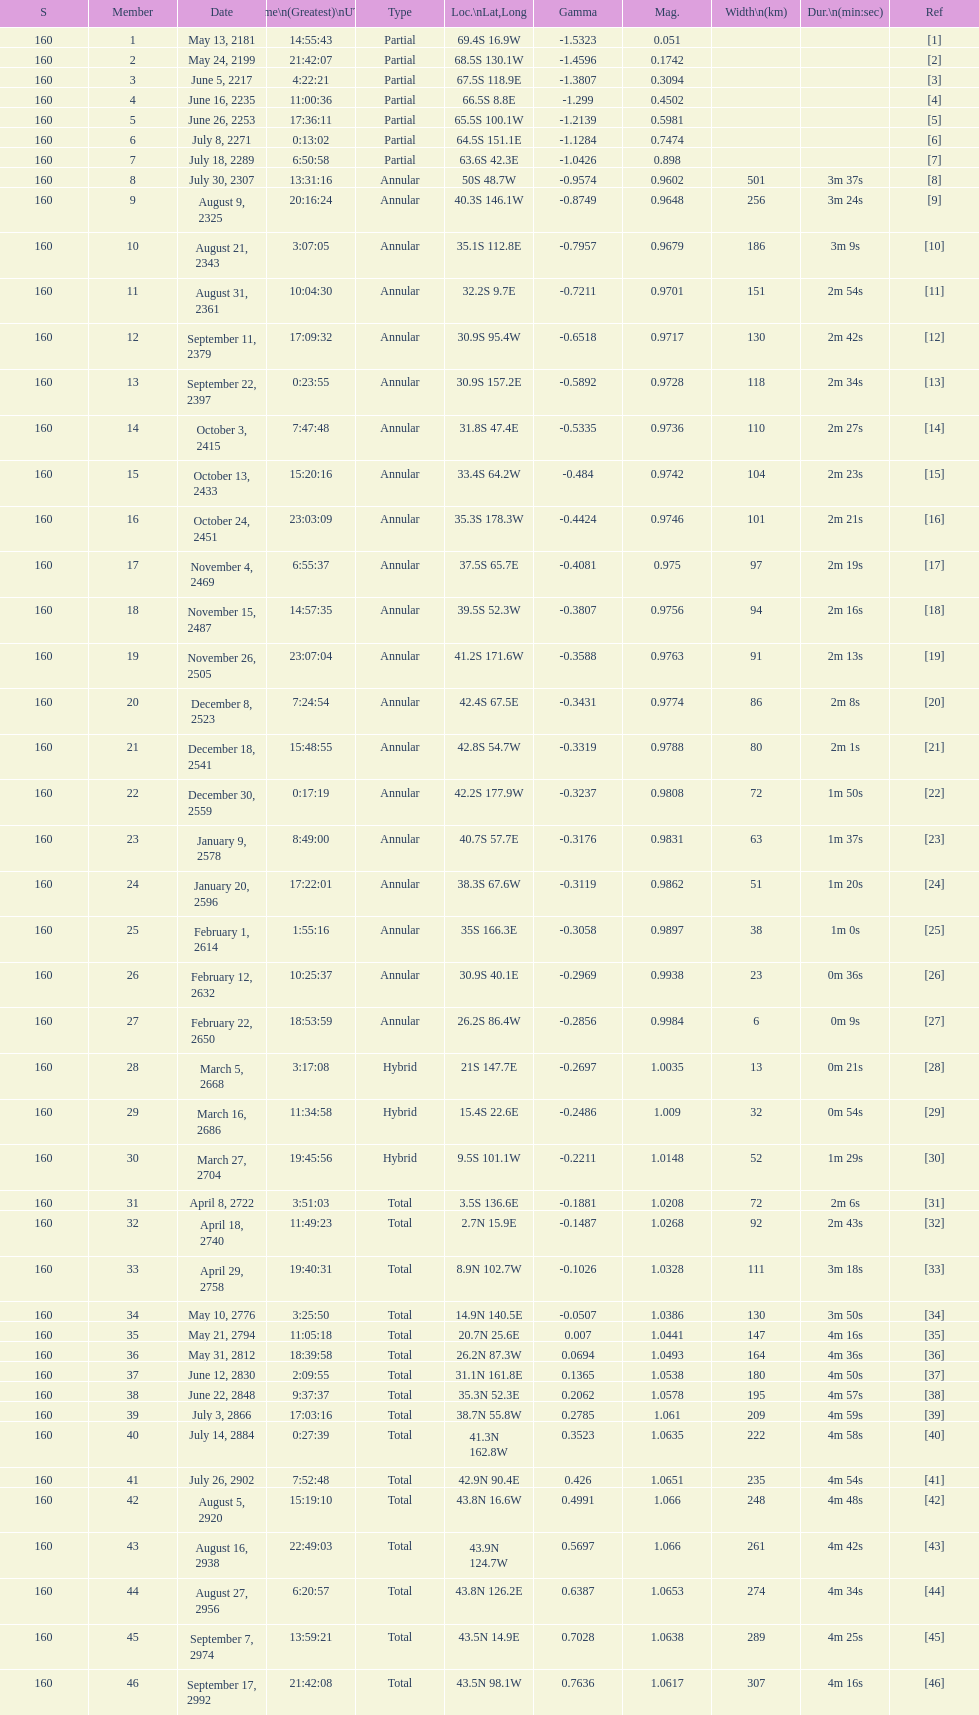How many solar saros events lasted longer than 4 minutes? 12. Can you give me this table as a dict? {'header': ['S', 'Member', 'Date', 'Time\\n(Greatest)\\nUTC', 'Type', 'Loc.\\nLat,Long', 'Gamma', 'Mag.', 'Width\\n(km)', 'Dur.\\n(min:sec)', 'Ref'], 'rows': [['160', '1', 'May 13, 2181', '14:55:43', 'Partial', '69.4S 16.9W', '-1.5323', '0.051', '', '', '[1]'], ['160', '2', 'May 24, 2199', '21:42:07', 'Partial', '68.5S 130.1W', '-1.4596', '0.1742', '', '', '[2]'], ['160', '3', 'June 5, 2217', '4:22:21', 'Partial', '67.5S 118.9E', '-1.3807', '0.3094', '', '', '[3]'], ['160', '4', 'June 16, 2235', '11:00:36', 'Partial', '66.5S 8.8E', '-1.299', '0.4502', '', '', '[4]'], ['160', '5', 'June 26, 2253', '17:36:11', 'Partial', '65.5S 100.1W', '-1.2139', '0.5981', '', '', '[5]'], ['160', '6', 'July 8, 2271', '0:13:02', 'Partial', '64.5S 151.1E', '-1.1284', '0.7474', '', '', '[6]'], ['160', '7', 'July 18, 2289', '6:50:58', 'Partial', '63.6S 42.3E', '-1.0426', '0.898', '', '', '[7]'], ['160', '8', 'July 30, 2307', '13:31:16', 'Annular', '50S 48.7W', '-0.9574', '0.9602', '501', '3m 37s', '[8]'], ['160', '9', 'August 9, 2325', '20:16:24', 'Annular', '40.3S 146.1W', '-0.8749', '0.9648', '256', '3m 24s', '[9]'], ['160', '10', 'August 21, 2343', '3:07:05', 'Annular', '35.1S 112.8E', '-0.7957', '0.9679', '186', '3m 9s', '[10]'], ['160', '11', 'August 31, 2361', '10:04:30', 'Annular', '32.2S 9.7E', '-0.7211', '0.9701', '151', '2m 54s', '[11]'], ['160', '12', 'September 11, 2379', '17:09:32', 'Annular', '30.9S 95.4W', '-0.6518', '0.9717', '130', '2m 42s', '[12]'], ['160', '13', 'September 22, 2397', '0:23:55', 'Annular', '30.9S 157.2E', '-0.5892', '0.9728', '118', '2m 34s', '[13]'], ['160', '14', 'October 3, 2415', '7:47:48', 'Annular', '31.8S 47.4E', '-0.5335', '0.9736', '110', '2m 27s', '[14]'], ['160', '15', 'October 13, 2433', '15:20:16', 'Annular', '33.4S 64.2W', '-0.484', '0.9742', '104', '2m 23s', '[15]'], ['160', '16', 'October 24, 2451', '23:03:09', 'Annular', '35.3S 178.3W', '-0.4424', '0.9746', '101', '2m 21s', '[16]'], ['160', '17', 'November 4, 2469', '6:55:37', 'Annular', '37.5S 65.7E', '-0.4081', '0.975', '97', '2m 19s', '[17]'], ['160', '18', 'November 15, 2487', '14:57:35', 'Annular', '39.5S 52.3W', '-0.3807', '0.9756', '94', '2m 16s', '[18]'], ['160', '19', 'November 26, 2505', '23:07:04', 'Annular', '41.2S 171.6W', '-0.3588', '0.9763', '91', '2m 13s', '[19]'], ['160', '20', 'December 8, 2523', '7:24:54', 'Annular', '42.4S 67.5E', '-0.3431', '0.9774', '86', '2m 8s', '[20]'], ['160', '21', 'December 18, 2541', '15:48:55', 'Annular', '42.8S 54.7W', '-0.3319', '0.9788', '80', '2m 1s', '[21]'], ['160', '22', 'December 30, 2559', '0:17:19', 'Annular', '42.2S 177.9W', '-0.3237', '0.9808', '72', '1m 50s', '[22]'], ['160', '23', 'January 9, 2578', '8:49:00', 'Annular', '40.7S 57.7E', '-0.3176', '0.9831', '63', '1m 37s', '[23]'], ['160', '24', 'January 20, 2596', '17:22:01', 'Annular', '38.3S 67.6W', '-0.3119', '0.9862', '51', '1m 20s', '[24]'], ['160', '25', 'February 1, 2614', '1:55:16', 'Annular', '35S 166.3E', '-0.3058', '0.9897', '38', '1m 0s', '[25]'], ['160', '26', 'February 12, 2632', '10:25:37', 'Annular', '30.9S 40.1E', '-0.2969', '0.9938', '23', '0m 36s', '[26]'], ['160', '27', 'February 22, 2650', '18:53:59', 'Annular', '26.2S 86.4W', '-0.2856', '0.9984', '6', '0m 9s', '[27]'], ['160', '28', 'March 5, 2668', '3:17:08', 'Hybrid', '21S 147.7E', '-0.2697', '1.0035', '13', '0m 21s', '[28]'], ['160', '29', 'March 16, 2686', '11:34:58', 'Hybrid', '15.4S 22.6E', '-0.2486', '1.009', '32', '0m 54s', '[29]'], ['160', '30', 'March 27, 2704', '19:45:56', 'Hybrid', '9.5S 101.1W', '-0.2211', '1.0148', '52', '1m 29s', '[30]'], ['160', '31', 'April 8, 2722', '3:51:03', 'Total', '3.5S 136.6E', '-0.1881', '1.0208', '72', '2m 6s', '[31]'], ['160', '32', 'April 18, 2740', '11:49:23', 'Total', '2.7N 15.9E', '-0.1487', '1.0268', '92', '2m 43s', '[32]'], ['160', '33', 'April 29, 2758', '19:40:31', 'Total', '8.9N 102.7W', '-0.1026', '1.0328', '111', '3m 18s', '[33]'], ['160', '34', 'May 10, 2776', '3:25:50', 'Total', '14.9N 140.5E', '-0.0507', '1.0386', '130', '3m 50s', '[34]'], ['160', '35', 'May 21, 2794', '11:05:18', 'Total', '20.7N 25.6E', '0.007', '1.0441', '147', '4m 16s', '[35]'], ['160', '36', 'May 31, 2812', '18:39:58', 'Total', '26.2N 87.3W', '0.0694', '1.0493', '164', '4m 36s', '[36]'], ['160', '37', 'June 12, 2830', '2:09:55', 'Total', '31.1N 161.8E', '0.1365', '1.0538', '180', '4m 50s', '[37]'], ['160', '38', 'June 22, 2848', '9:37:37', 'Total', '35.3N 52.3E', '0.2062', '1.0578', '195', '4m 57s', '[38]'], ['160', '39', 'July 3, 2866', '17:03:16', 'Total', '38.7N 55.8W', '0.2785', '1.061', '209', '4m 59s', '[39]'], ['160', '40', 'July 14, 2884', '0:27:39', 'Total', '41.3N 162.8W', '0.3523', '1.0635', '222', '4m 58s', '[40]'], ['160', '41', 'July 26, 2902', '7:52:48', 'Total', '42.9N 90.4E', '0.426', '1.0651', '235', '4m 54s', '[41]'], ['160', '42', 'August 5, 2920', '15:19:10', 'Total', '43.8N 16.6W', '0.4991', '1.066', '248', '4m 48s', '[42]'], ['160', '43', 'August 16, 2938', '22:49:03', 'Total', '43.9N 124.7W', '0.5697', '1.066', '261', '4m 42s', '[43]'], ['160', '44', 'August 27, 2956', '6:20:57', 'Total', '43.8N 126.2E', '0.6387', '1.0653', '274', '4m 34s', '[44]'], ['160', '45', 'September 7, 2974', '13:59:21', 'Total', '43.5N 14.9E', '0.7028', '1.0638', '289', '4m 25s', '[45]'], ['160', '46', 'September 17, 2992', '21:42:08', 'Total', '43.5N 98.1W', '0.7636', '1.0617', '307', '4m 16s', '[46]']]} 